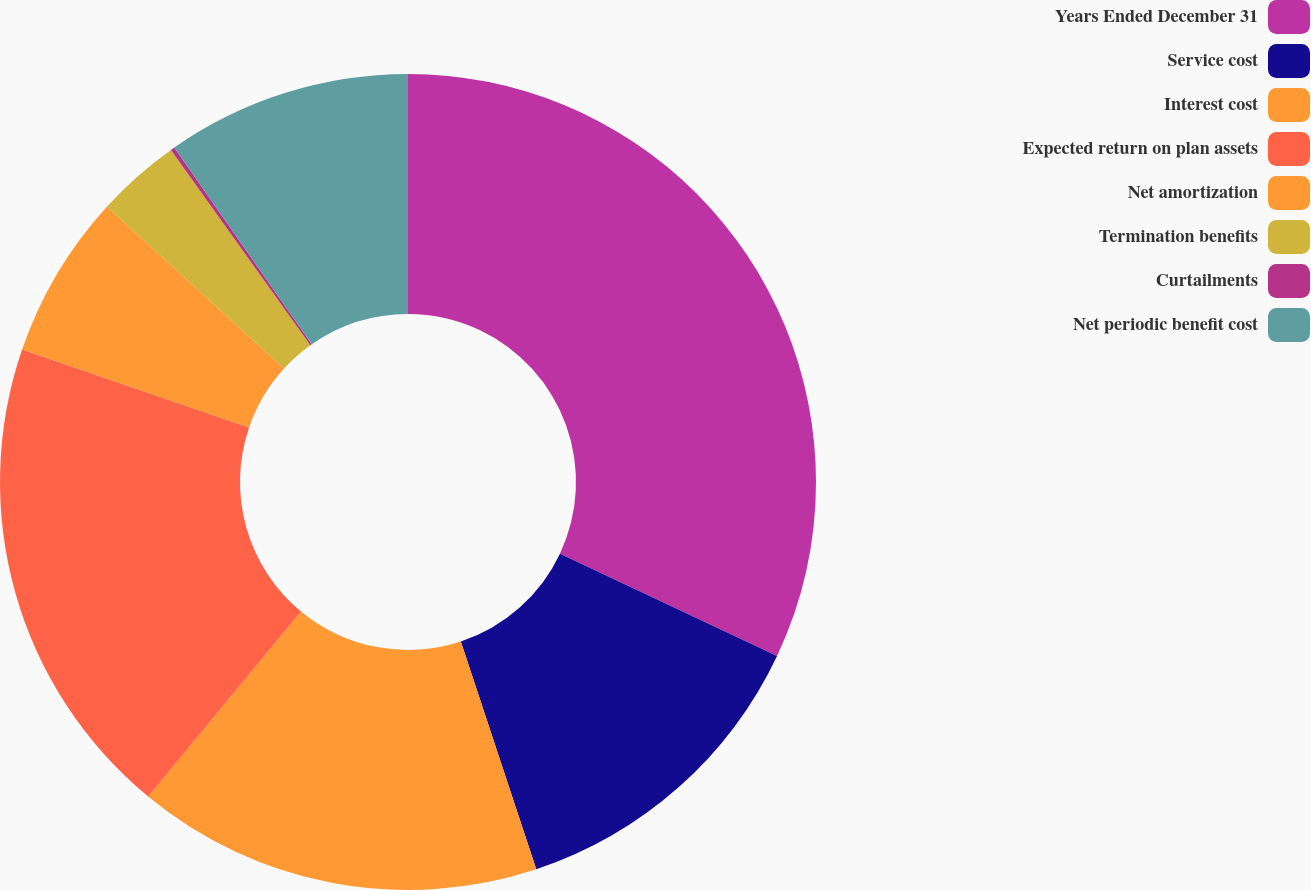Convert chart to OTSL. <chart><loc_0><loc_0><loc_500><loc_500><pie_chart><fcel>Years Ended December 31<fcel>Service cost<fcel>Interest cost<fcel>Expected return on plan assets<fcel>Net amortization<fcel>Termination benefits<fcel>Curtailments<fcel>Net periodic benefit cost<nl><fcel>32.01%<fcel>12.9%<fcel>16.08%<fcel>19.27%<fcel>6.53%<fcel>3.34%<fcel>0.16%<fcel>9.71%<nl></chart> 